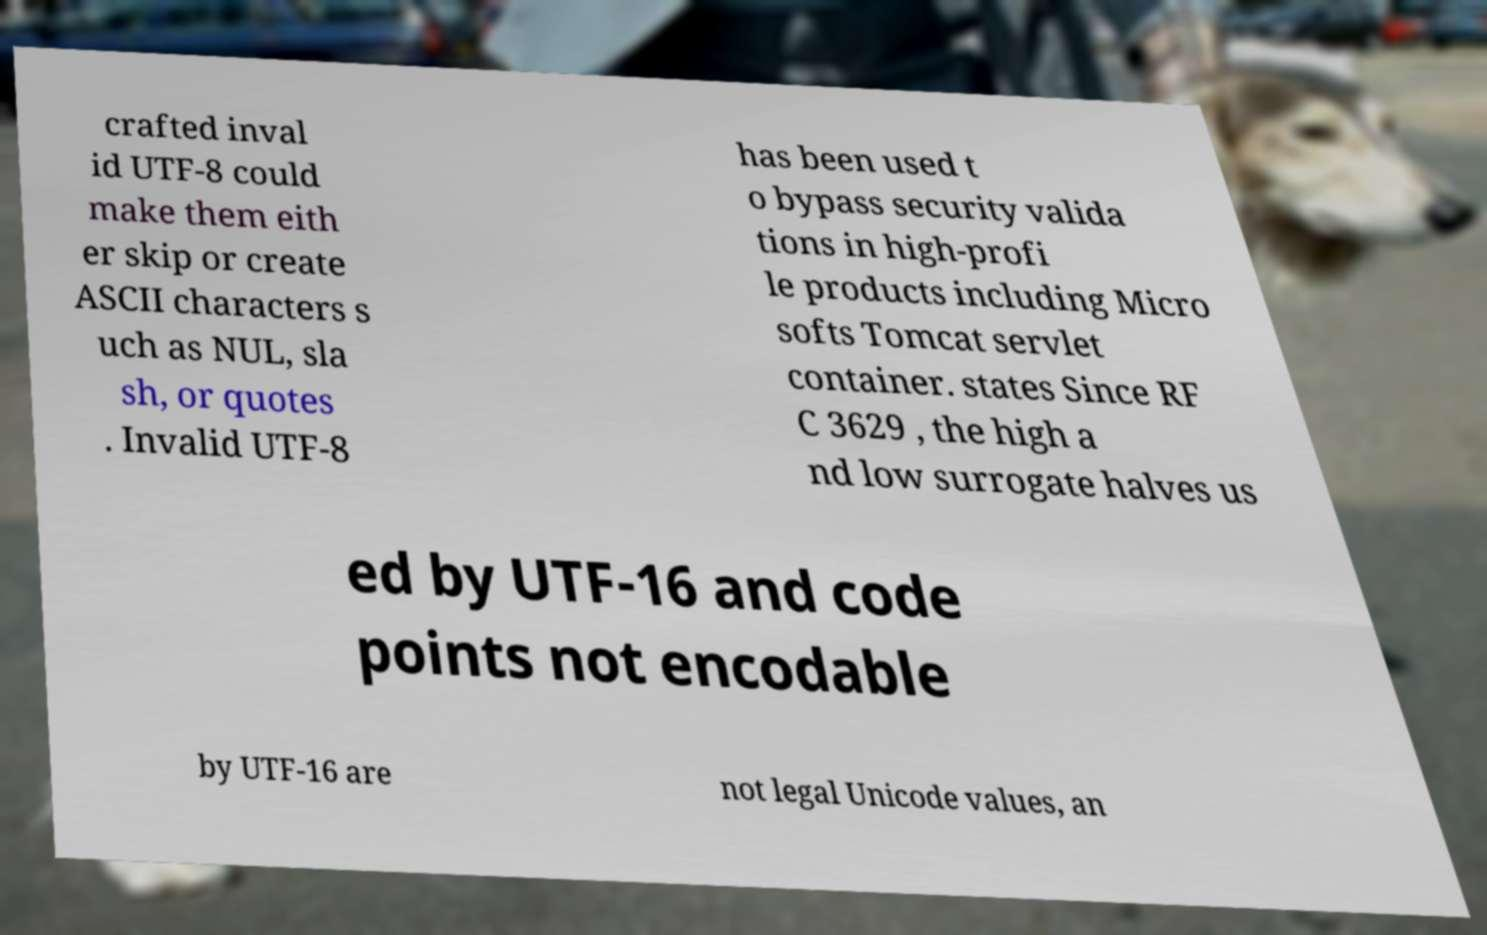There's text embedded in this image that I need extracted. Can you transcribe it verbatim? crafted inval id UTF-8 could make them eith er skip or create ASCII characters s uch as NUL, sla sh, or quotes . Invalid UTF-8 has been used t o bypass security valida tions in high-profi le products including Micro softs Tomcat servlet container. states Since RF C 3629 , the high a nd low surrogate halves us ed by UTF-16 and code points not encodable by UTF-16 are not legal Unicode values, an 